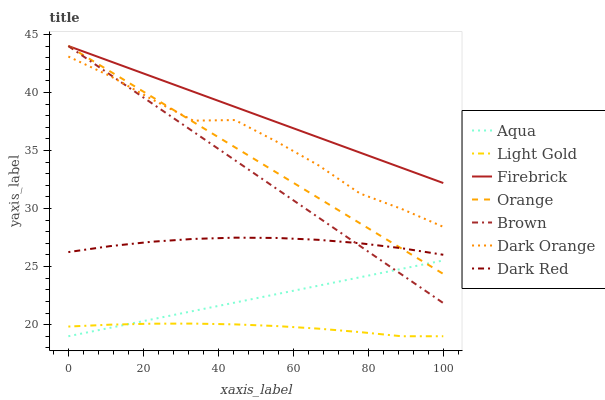Does Light Gold have the minimum area under the curve?
Answer yes or no. Yes. Does Firebrick have the maximum area under the curve?
Answer yes or no. Yes. Does Brown have the minimum area under the curve?
Answer yes or no. No. Does Brown have the maximum area under the curve?
Answer yes or no. No. Is Aqua the smoothest?
Answer yes or no. Yes. Is Dark Orange the roughest?
Answer yes or no. Yes. Is Brown the smoothest?
Answer yes or no. No. Is Brown the roughest?
Answer yes or no. No. Does Brown have the lowest value?
Answer yes or no. No. Does Orange have the highest value?
Answer yes or no. Yes. Does Dark Red have the highest value?
Answer yes or no. No. Is Dark Red less than Firebrick?
Answer yes or no. Yes. Is Dark Orange greater than Dark Red?
Answer yes or no. Yes. Does Brown intersect Aqua?
Answer yes or no. Yes. Is Brown less than Aqua?
Answer yes or no. No. Is Brown greater than Aqua?
Answer yes or no. No. Does Dark Red intersect Firebrick?
Answer yes or no. No. 